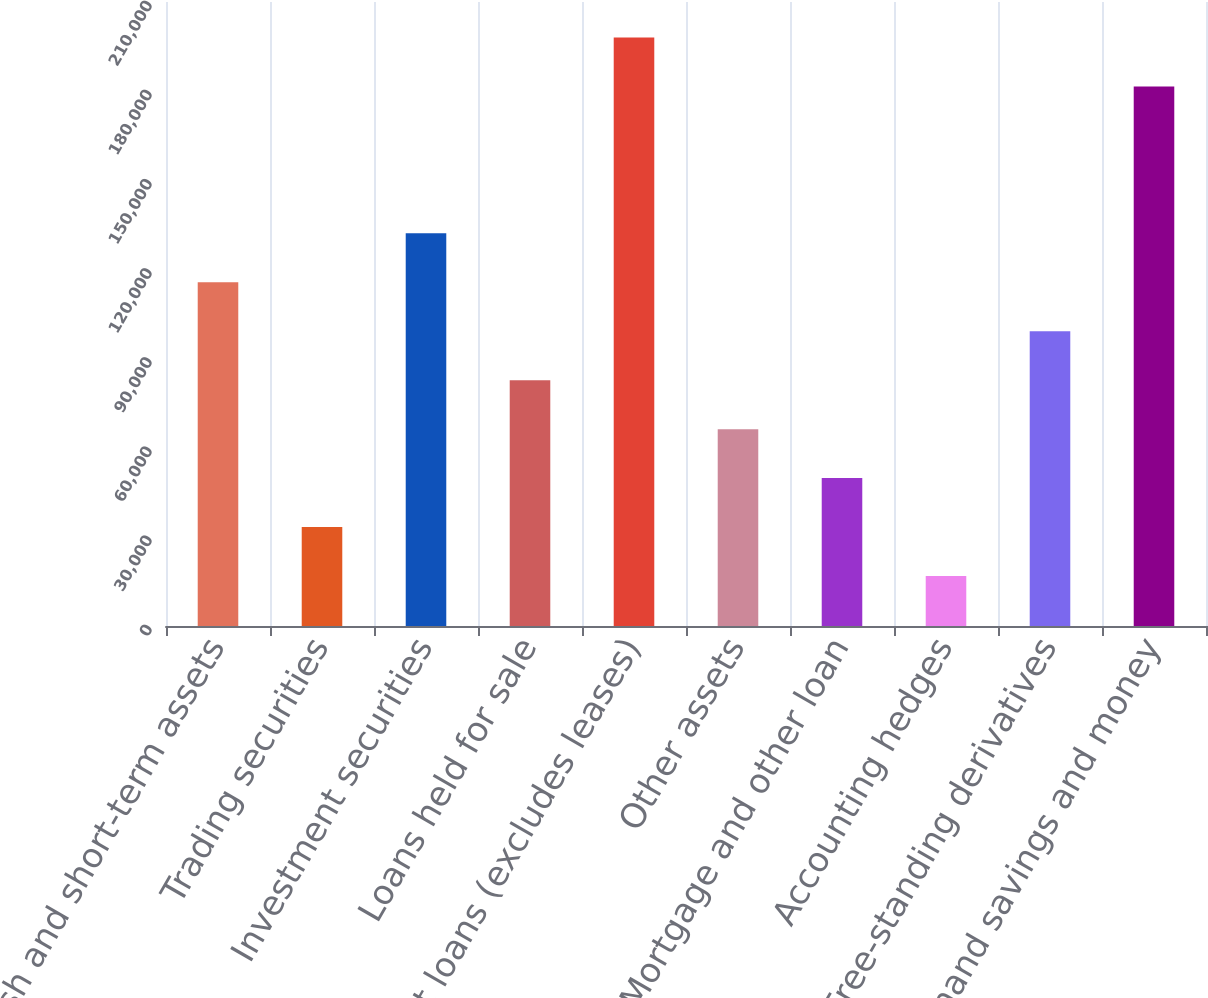Convert chart. <chart><loc_0><loc_0><loc_500><loc_500><bar_chart><fcel>Cash and short-term assets<fcel>Trading securities<fcel>Investment securities<fcel>Loans held for sale<fcel>Net loans (excludes leases)<fcel>Other assets<fcel>Mortgage and other loan<fcel>Accounting hedges<fcel>Free-standing derivatives<fcel>Demand savings and money<nl><fcel>115680<fcel>33292.8<fcel>132157<fcel>82725<fcel>198067<fcel>66247.6<fcel>49770.2<fcel>16815.4<fcel>99202.4<fcel>181589<nl></chart> 